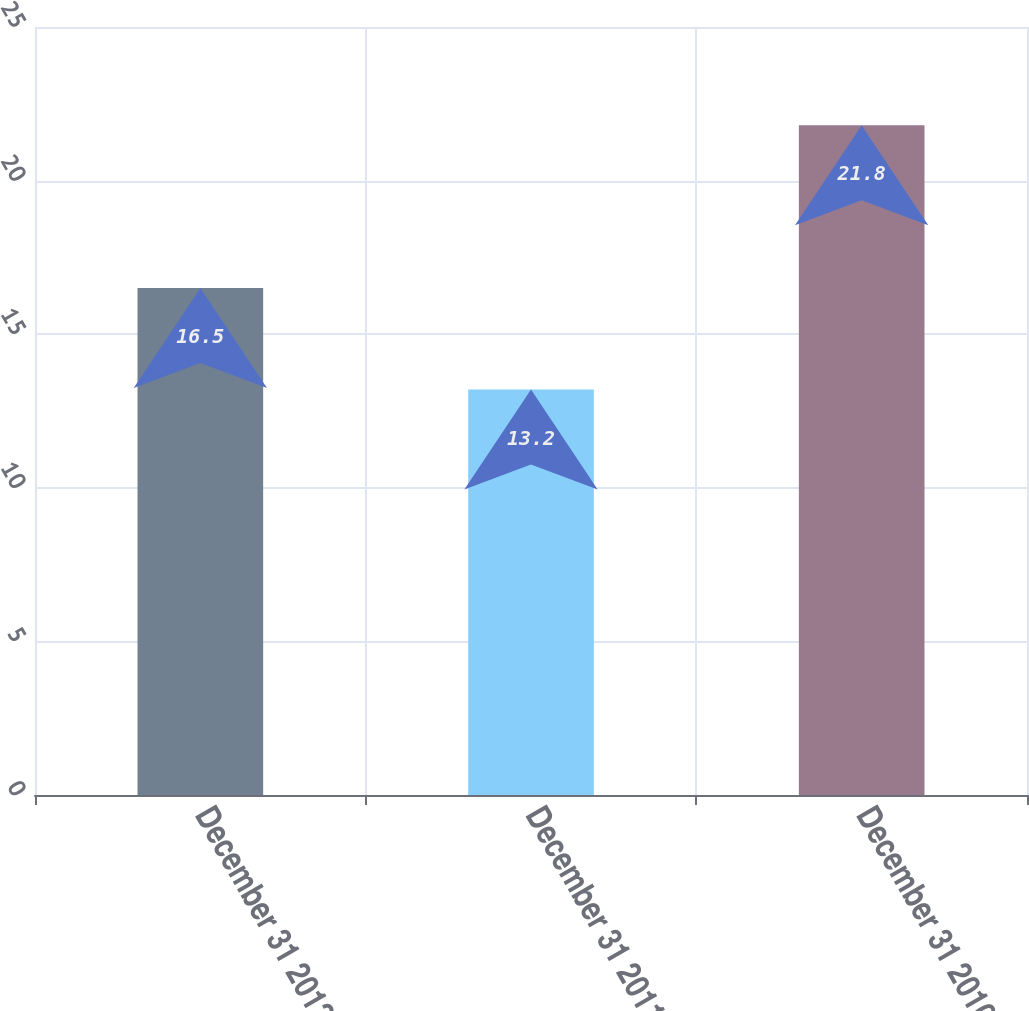Convert chart to OTSL. <chart><loc_0><loc_0><loc_500><loc_500><bar_chart><fcel>December 31 2012<fcel>December 31 2011<fcel>December 31 2010<nl><fcel>16.5<fcel>13.2<fcel>21.8<nl></chart> 